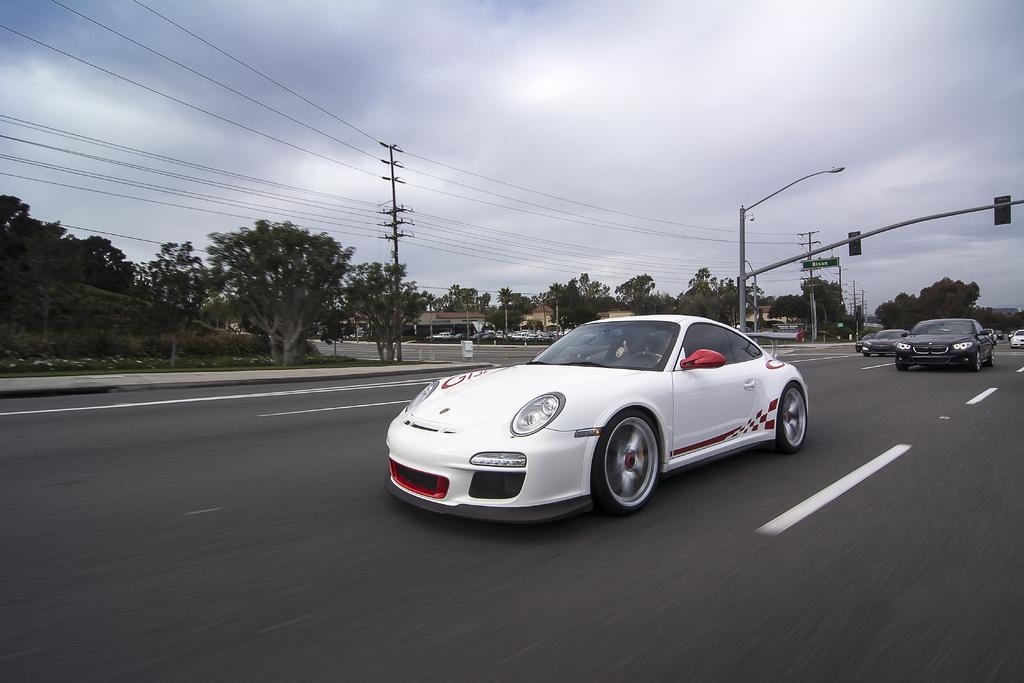In one or two sentences, can you explain what this image depicts? In this image we can see the vehicles passing on the road. Image also consists of electrical poles with wires, light poles and also many trees. There is a cloudy sky. 